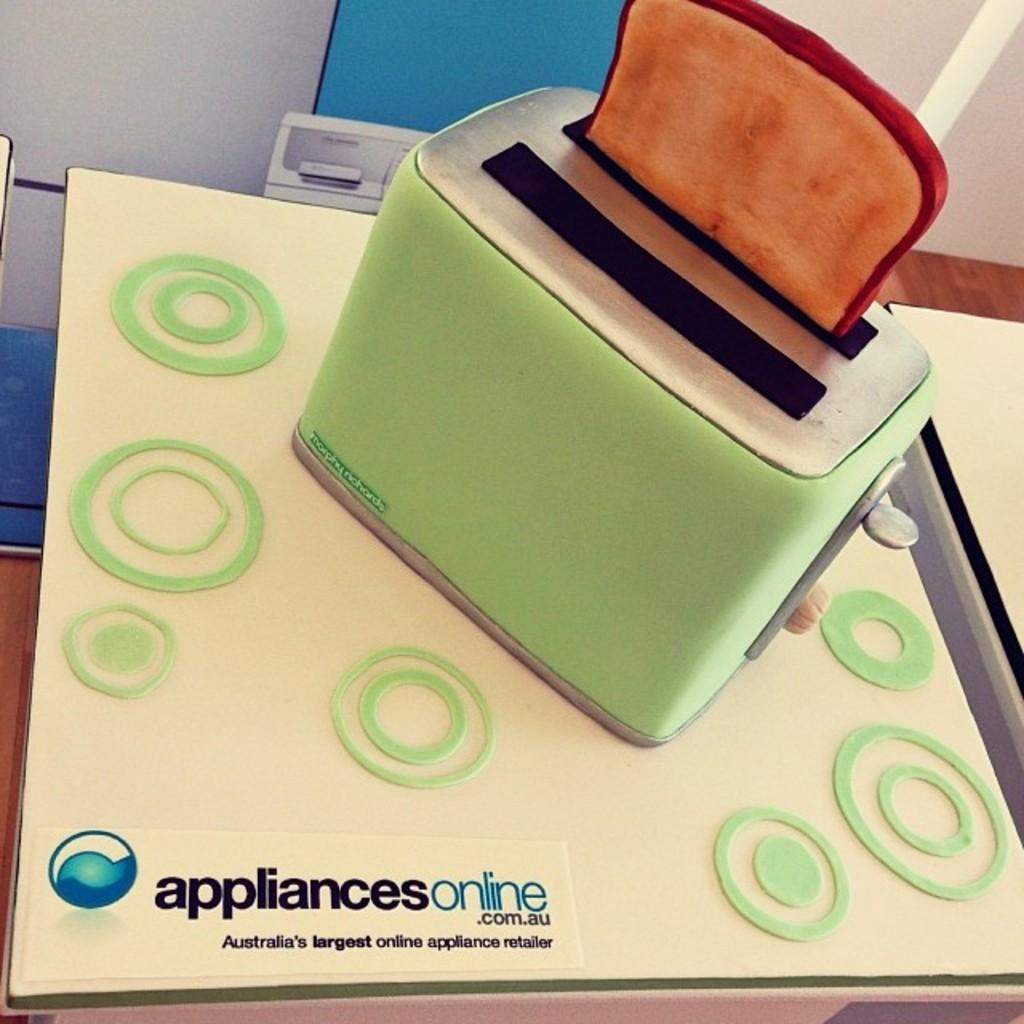What appliance can be seen in the image? There is a toaster in the image. What is inside the toaster? There is a toast in the toaster. On what surface is the toaster placed? The toaster is placed on a surface. What can be seen in the background of the image? There is a wall in the background of the image. How many passengers are visible in the image? There are no passengers present in the image; it features a toaster with toast inside. What type of basket is hanging on the wall in the image? There is no basket present in the image; it only shows a toaster with toast inside and a wall in the background. 